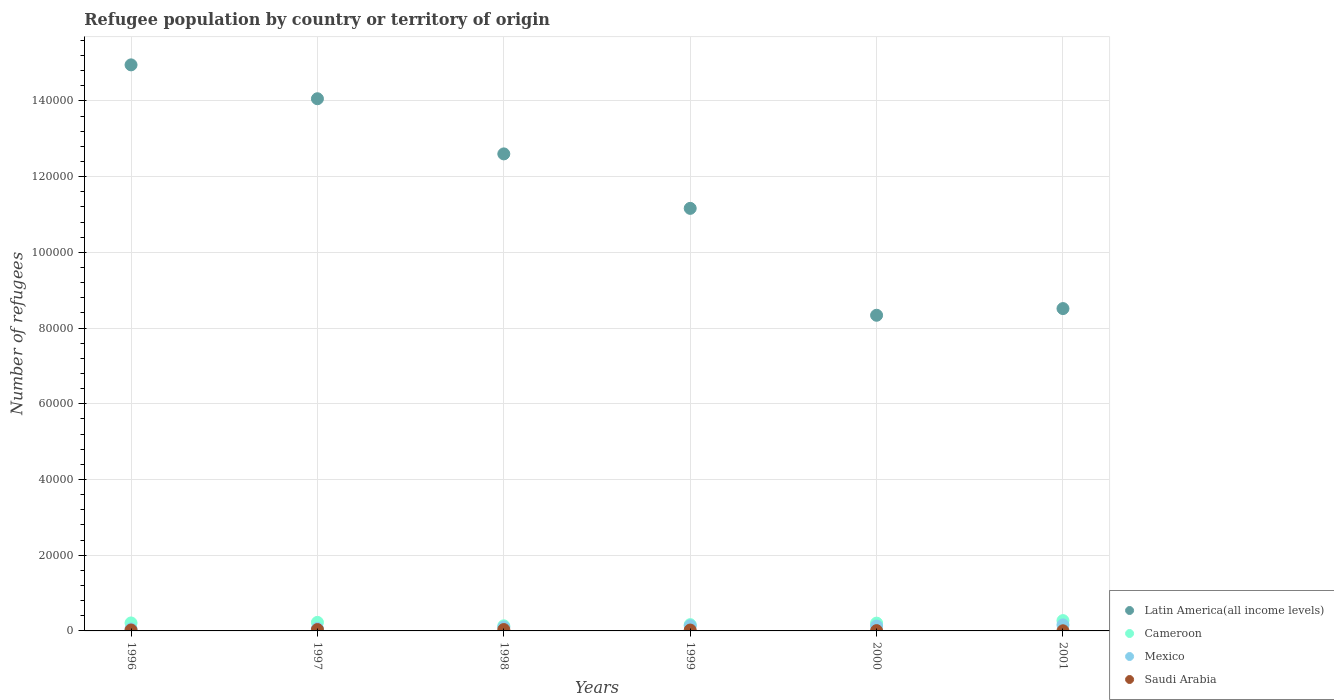Is the number of dotlines equal to the number of legend labels?
Your answer should be compact. Yes. What is the number of refugees in Saudi Arabia in 1999?
Give a very brief answer. 233. Across all years, what is the maximum number of refugees in Mexico?
Give a very brief answer. 1594. In which year was the number of refugees in Mexico maximum?
Offer a very short reply. 2001. What is the total number of refugees in Latin America(all income levels) in the graph?
Your answer should be compact. 6.96e+05. What is the difference between the number of refugees in Cameroon in 1999 and that in 2000?
Your answer should be very brief. -408. What is the difference between the number of refugees in Saudi Arabia in 1997 and the number of refugees in Mexico in 1999?
Offer a terse response. -1001. What is the average number of refugees in Mexico per year?
Ensure brevity in your answer.  1074.17. In the year 1998, what is the difference between the number of refugees in Latin America(all income levels) and number of refugees in Mexico?
Your response must be concise. 1.25e+05. In how many years, is the number of refugees in Cameroon greater than 148000?
Your answer should be very brief. 0. What is the ratio of the number of refugees in Mexico in 1997 to that in 2001?
Keep it short and to the point. 0.42. Is the number of refugees in Cameroon in 1996 less than that in 1999?
Provide a short and direct response. No. What is the difference between the highest and the second highest number of refugees in Latin America(all income levels)?
Offer a terse response. 8946. What is the difference between the highest and the lowest number of refugees in Latin America(all income levels)?
Your answer should be compact. 6.61e+04. Is it the case that in every year, the sum of the number of refugees in Saudi Arabia and number of refugees in Latin America(all income levels)  is greater than the number of refugees in Mexico?
Your answer should be very brief. Yes. Are the values on the major ticks of Y-axis written in scientific E-notation?
Provide a succinct answer. No. Does the graph contain any zero values?
Keep it short and to the point. No. Does the graph contain grids?
Give a very brief answer. Yes. How are the legend labels stacked?
Your answer should be compact. Vertical. What is the title of the graph?
Make the answer very short. Refugee population by country or territory of origin. What is the label or title of the X-axis?
Your response must be concise. Years. What is the label or title of the Y-axis?
Give a very brief answer. Number of refugees. What is the Number of refugees in Latin America(all income levels) in 1996?
Give a very brief answer. 1.50e+05. What is the Number of refugees of Cameroon in 1996?
Keep it short and to the point. 2109. What is the Number of refugees of Mexico in 1996?
Your answer should be compact. 520. What is the Number of refugees of Saudi Arabia in 1996?
Provide a short and direct response. 242. What is the Number of refugees in Latin America(all income levels) in 1997?
Make the answer very short. 1.41e+05. What is the Number of refugees of Cameroon in 1997?
Give a very brief answer. 2258. What is the Number of refugees of Mexico in 1997?
Provide a short and direct response. 665. What is the Number of refugees in Saudi Arabia in 1997?
Give a very brief answer. 358. What is the Number of refugees of Latin America(all income levels) in 1998?
Provide a succinct answer. 1.26e+05. What is the Number of refugees in Cameroon in 1998?
Keep it short and to the point. 1348. What is the Number of refugees of Mexico in 1998?
Keep it short and to the point. 1016. What is the Number of refugees of Saudi Arabia in 1998?
Provide a short and direct response. 362. What is the Number of refugees in Latin America(all income levels) in 1999?
Your response must be concise. 1.12e+05. What is the Number of refugees of Cameroon in 1999?
Your answer should be very brief. 1654. What is the Number of refugees in Mexico in 1999?
Your answer should be very brief. 1359. What is the Number of refugees in Saudi Arabia in 1999?
Keep it short and to the point. 233. What is the Number of refugees of Latin America(all income levels) in 2000?
Ensure brevity in your answer.  8.34e+04. What is the Number of refugees in Cameroon in 2000?
Provide a succinct answer. 2062. What is the Number of refugees in Mexico in 2000?
Keep it short and to the point. 1291. What is the Number of refugees of Latin America(all income levels) in 2001?
Offer a terse response. 8.52e+04. What is the Number of refugees in Cameroon in 2001?
Your answer should be compact. 2724. What is the Number of refugees of Mexico in 2001?
Offer a very short reply. 1594. What is the Number of refugees in Saudi Arabia in 2001?
Offer a terse response. 35. Across all years, what is the maximum Number of refugees of Latin America(all income levels)?
Ensure brevity in your answer.  1.50e+05. Across all years, what is the maximum Number of refugees of Cameroon?
Give a very brief answer. 2724. Across all years, what is the maximum Number of refugees of Mexico?
Ensure brevity in your answer.  1594. Across all years, what is the maximum Number of refugees of Saudi Arabia?
Make the answer very short. 362. Across all years, what is the minimum Number of refugees of Latin America(all income levels)?
Make the answer very short. 8.34e+04. Across all years, what is the minimum Number of refugees of Cameroon?
Provide a short and direct response. 1348. Across all years, what is the minimum Number of refugees of Mexico?
Make the answer very short. 520. Across all years, what is the minimum Number of refugees of Saudi Arabia?
Offer a terse response. 35. What is the total Number of refugees in Latin America(all income levels) in the graph?
Give a very brief answer. 6.96e+05. What is the total Number of refugees in Cameroon in the graph?
Give a very brief answer. 1.22e+04. What is the total Number of refugees of Mexico in the graph?
Ensure brevity in your answer.  6445. What is the total Number of refugees of Saudi Arabia in the graph?
Provide a succinct answer. 1307. What is the difference between the Number of refugees in Latin America(all income levels) in 1996 and that in 1997?
Your response must be concise. 8946. What is the difference between the Number of refugees of Cameroon in 1996 and that in 1997?
Your response must be concise. -149. What is the difference between the Number of refugees in Mexico in 1996 and that in 1997?
Your response must be concise. -145. What is the difference between the Number of refugees of Saudi Arabia in 1996 and that in 1997?
Your response must be concise. -116. What is the difference between the Number of refugees in Latin America(all income levels) in 1996 and that in 1998?
Give a very brief answer. 2.35e+04. What is the difference between the Number of refugees of Cameroon in 1996 and that in 1998?
Provide a succinct answer. 761. What is the difference between the Number of refugees in Mexico in 1996 and that in 1998?
Offer a terse response. -496. What is the difference between the Number of refugees in Saudi Arabia in 1996 and that in 1998?
Your response must be concise. -120. What is the difference between the Number of refugees of Latin America(all income levels) in 1996 and that in 1999?
Make the answer very short. 3.79e+04. What is the difference between the Number of refugees of Cameroon in 1996 and that in 1999?
Make the answer very short. 455. What is the difference between the Number of refugees of Mexico in 1996 and that in 1999?
Your answer should be compact. -839. What is the difference between the Number of refugees in Saudi Arabia in 1996 and that in 1999?
Offer a terse response. 9. What is the difference between the Number of refugees in Latin America(all income levels) in 1996 and that in 2000?
Ensure brevity in your answer.  6.61e+04. What is the difference between the Number of refugees of Cameroon in 1996 and that in 2000?
Offer a terse response. 47. What is the difference between the Number of refugees of Mexico in 1996 and that in 2000?
Offer a very short reply. -771. What is the difference between the Number of refugees of Saudi Arabia in 1996 and that in 2000?
Give a very brief answer. 165. What is the difference between the Number of refugees in Latin America(all income levels) in 1996 and that in 2001?
Make the answer very short. 6.44e+04. What is the difference between the Number of refugees in Cameroon in 1996 and that in 2001?
Make the answer very short. -615. What is the difference between the Number of refugees of Mexico in 1996 and that in 2001?
Make the answer very short. -1074. What is the difference between the Number of refugees of Saudi Arabia in 1996 and that in 2001?
Provide a short and direct response. 207. What is the difference between the Number of refugees in Latin America(all income levels) in 1997 and that in 1998?
Give a very brief answer. 1.46e+04. What is the difference between the Number of refugees of Cameroon in 1997 and that in 1998?
Give a very brief answer. 910. What is the difference between the Number of refugees in Mexico in 1997 and that in 1998?
Provide a short and direct response. -351. What is the difference between the Number of refugees in Latin America(all income levels) in 1997 and that in 1999?
Offer a very short reply. 2.90e+04. What is the difference between the Number of refugees in Cameroon in 1997 and that in 1999?
Offer a very short reply. 604. What is the difference between the Number of refugees in Mexico in 1997 and that in 1999?
Your answer should be compact. -694. What is the difference between the Number of refugees of Saudi Arabia in 1997 and that in 1999?
Make the answer very short. 125. What is the difference between the Number of refugees in Latin America(all income levels) in 1997 and that in 2000?
Ensure brevity in your answer.  5.72e+04. What is the difference between the Number of refugees of Cameroon in 1997 and that in 2000?
Your response must be concise. 196. What is the difference between the Number of refugees of Mexico in 1997 and that in 2000?
Ensure brevity in your answer.  -626. What is the difference between the Number of refugees of Saudi Arabia in 1997 and that in 2000?
Your response must be concise. 281. What is the difference between the Number of refugees in Latin America(all income levels) in 1997 and that in 2001?
Your answer should be compact. 5.54e+04. What is the difference between the Number of refugees in Cameroon in 1997 and that in 2001?
Provide a short and direct response. -466. What is the difference between the Number of refugees in Mexico in 1997 and that in 2001?
Keep it short and to the point. -929. What is the difference between the Number of refugees in Saudi Arabia in 1997 and that in 2001?
Provide a succinct answer. 323. What is the difference between the Number of refugees in Latin America(all income levels) in 1998 and that in 1999?
Offer a very short reply. 1.44e+04. What is the difference between the Number of refugees of Cameroon in 1998 and that in 1999?
Provide a short and direct response. -306. What is the difference between the Number of refugees of Mexico in 1998 and that in 1999?
Make the answer very short. -343. What is the difference between the Number of refugees of Saudi Arabia in 1998 and that in 1999?
Provide a short and direct response. 129. What is the difference between the Number of refugees in Latin America(all income levels) in 1998 and that in 2000?
Offer a terse response. 4.26e+04. What is the difference between the Number of refugees in Cameroon in 1998 and that in 2000?
Provide a succinct answer. -714. What is the difference between the Number of refugees in Mexico in 1998 and that in 2000?
Give a very brief answer. -275. What is the difference between the Number of refugees of Saudi Arabia in 1998 and that in 2000?
Your answer should be very brief. 285. What is the difference between the Number of refugees in Latin America(all income levels) in 1998 and that in 2001?
Make the answer very short. 4.09e+04. What is the difference between the Number of refugees in Cameroon in 1998 and that in 2001?
Offer a terse response. -1376. What is the difference between the Number of refugees in Mexico in 1998 and that in 2001?
Give a very brief answer. -578. What is the difference between the Number of refugees in Saudi Arabia in 1998 and that in 2001?
Give a very brief answer. 327. What is the difference between the Number of refugees in Latin America(all income levels) in 1999 and that in 2000?
Your answer should be very brief. 2.82e+04. What is the difference between the Number of refugees of Cameroon in 1999 and that in 2000?
Keep it short and to the point. -408. What is the difference between the Number of refugees in Saudi Arabia in 1999 and that in 2000?
Offer a terse response. 156. What is the difference between the Number of refugees of Latin America(all income levels) in 1999 and that in 2001?
Offer a very short reply. 2.65e+04. What is the difference between the Number of refugees in Cameroon in 1999 and that in 2001?
Keep it short and to the point. -1070. What is the difference between the Number of refugees in Mexico in 1999 and that in 2001?
Your answer should be very brief. -235. What is the difference between the Number of refugees of Saudi Arabia in 1999 and that in 2001?
Ensure brevity in your answer.  198. What is the difference between the Number of refugees in Latin America(all income levels) in 2000 and that in 2001?
Offer a very short reply. -1765. What is the difference between the Number of refugees in Cameroon in 2000 and that in 2001?
Make the answer very short. -662. What is the difference between the Number of refugees of Mexico in 2000 and that in 2001?
Your answer should be very brief. -303. What is the difference between the Number of refugees of Latin America(all income levels) in 1996 and the Number of refugees of Cameroon in 1997?
Your answer should be very brief. 1.47e+05. What is the difference between the Number of refugees in Latin America(all income levels) in 1996 and the Number of refugees in Mexico in 1997?
Make the answer very short. 1.49e+05. What is the difference between the Number of refugees in Latin America(all income levels) in 1996 and the Number of refugees in Saudi Arabia in 1997?
Offer a very short reply. 1.49e+05. What is the difference between the Number of refugees of Cameroon in 1996 and the Number of refugees of Mexico in 1997?
Ensure brevity in your answer.  1444. What is the difference between the Number of refugees of Cameroon in 1996 and the Number of refugees of Saudi Arabia in 1997?
Your answer should be compact. 1751. What is the difference between the Number of refugees of Mexico in 1996 and the Number of refugees of Saudi Arabia in 1997?
Provide a short and direct response. 162. What is the difference between the Number of refugees of Latin America(all income levels) in 1996 and the Number of refugees of Cameroon in 1998?
Provide a succinct answer. 1.48e+05. What is the difference between the Number of refugees in Latin America(all income levels) in 1996 and the Number of refugees in Mexico in 1998?
Your answer should be very brief. 1.49e+05. What is the difference between the Number of refugees of Latin America(all income levels) in 1996 and the Number of refugees of Saudi Arabia in 1998?
Offer a terse response. 1.49e+05. What is the difference between the Number of refugees in Cameroon in 1996 and the Number of refugees in Mexico in 1998?
Your response must be concise. 1093. What is the difference between the Number of refugees in Cameroon in 1996 and the Number of refugees in Saudi Arabia in 1998?
Keep it short and to the point. 1747. What is the difference between the Number of refugees of Mexico in 1996 and the Number of refugees of Saudi Arabia in 1998?
Keep it short and to the point. 158. What is the difference between the Number of refugees in Latin America(all income levels) in 1996 and the Number of refugees in Cameroon in 1999?
Keep it short and to the point. 1.48e+05. What is the difference between the Number of refugees in Latin America(all income levels) in 1996 and the Number of refugees in Mexico in 1999?
Provide a succinct answer. 1.48e+05. What is the difference between the Number of refugees of Latin America(all income levels) in 1996 and the Number of refugees of Saudi Arabia in 1999?
Your answer should be very brief. 1.49e+05. What is the difference between the Number of refugees of Cameroon in 1996 and the Number of refugees of Mexico in 1999?
Offer a terse response. 750. What is the difference between the Number of refugees of Cameroon in 1996 and the Number of refugees of Saudi Arabia in 1999?
Provide a succinct answer. 1876. What is the difference between the Number of refugees in Mexico in 1996 and the Number of refugees in Saudi Arabia in 1999?
Offer a terse response. 287. What is the difference between the Number of refugees in Latin America(all income levels) in 1996 and the Number of refugees in Cameroon in 2000?
Provide a succinct answer. 1.47e+05. What is the difference between the Number of refugees of Latin America(all income levels) in 1996 and the Number of refugees of Mexico in 2000?
Offer a terse response. 1.48e+05. What is the difference between the Number of refugees of Latin America(all income levels) in 1996 and the Number of refugees of Saudi Arabia in 2000?
Offer a terse response. 1.49e+05. What is the difference between the Number of refugees of Cameroon in 1996 and the Number of refugees of Mexico in 2000?
Offer a terse response. 818. What is the difference between the Number of refugees in Cameroon in 1996 and the Number of refugees in Saudi Arabia in 2000?
Keep it short and to the point. 2032. What is the difference between the Number of refugees in Mexico in 1996 and the Number of refugees in Saudi Arabia in 2000?
Your answer should be very brief. 443. What is the difference between the Number of refugees of Latin America(all income levels) in 1996 and the Number of refugees of Cameroon in 2001?
Provide a succinct answer. 1.47e+05. What is the difference between the Number of refugees of Latin America(all income levels) in 1996 and the Number of refugees of Mexico in 2001?
Your answer should be compact. 1.48e+05. What is the difference between the Number of refugees of Latin America(all income levels) in 1996 and the Number of refugees of Saudi Arabia in 2001?
Offer a very short reply. 1.50e+05. What is the difference between the Number of refugees in Cameroon in 1996 and the Number of refugees in Mexico in 2001?
Your answer should be very brief. 515. What is the difference between the Number of refugees in Cameroon in 1996 and the Number of refugees in Saudi Arabia in 2001?
Your response must be concise. 2074. What is the difference between the Number of refugees of Mexico in 1996 and the Number of refugees of Saudi Arabia in 2001?
Keep it short and to the point. 485. What is the difference between the Number of refugees in Latin America(all income levels) in 1997 and the Number of refugees in Cameroon in 1998?
Give a very brief answer. 1.39e+05. What is the difference between the Number of refugees of Latin America(all income levels) in 1997 and the Number of refugees of Mexico in 1998?
Provide a succinct answer. 1.40e+05. What is the difference between the Number of refugees of Latin America(all income levels) in 1997 and the Number of refugees of Saudi Arabia in 1998?
Keep it short and to the point. 1.40e+05. What is the difference between the Number of refugees of Cameroon in 1997 and the Number of refugees of Mexico in 1998?
Provide a succinct answer. 1242. What is the difference between the Number of refugees in Cameroon in 1997 and the Number of refugees in Saudi Arabia in 1998?
Keep it short and to the point. 1896. What is the difference between the Number of refugees of Mexico in 1997 and the Number of refugees of Saudi Arabia in 1998?
Ensure brevity in your answer.  303. What is the difference between the Number of refugees in Latin America(all income levels) in 1997 and the Number of refugees in Cameroon in 1999?
Keep it short and to the point. 1.39e+05. What is the difference between the Number of refugees in Latin America(all income levels) in 1997 and the Number of refugees in Mexico in 1999?
Make the answer very short. 1.39e+05. What is the difference between the Number of refugees of Latin America(all income levels) in 1997 and the Number of refugees of Saudi Arabia in 1999?
Provide a succinct answer. 1.40e+05. What is the difference between the Number of refugees in Cameroon in 1997 and the Number of refugees in Mexico in 1999?
Provide a short and direct response. 899. What is the difference between the Number of refugees in Cameroon in 1997 and the Number of refugees in Saudi Arabia in 1999?
Ensure brevity in your answer.  2025. What is the difference between the Number of refugees in Mexico in 1997 and the Number of refugees in Saudi Arabia in 1999?
Give a very brief answer. 432. What is the difference between the Number of refugees of Latin America(all income levels) in 1997 and the Number of refugees of Cameroon in 2000?
Provide a short and direct response. 1.39e+05. What is the difference between the Number of refugees in Latin America(all income levels) in 1997 and the Number of refugees in Mexico in 2000?
Ensure brevity in your answer.  1.39e+05. What is the difference between the Number of refugees of Latin America(all income levels) in 1997 and the Number of refugees of Saudi Arabia in 2000?
Make the answer very short. 1.41e+05. What is the difference between the Number of refugees of Cameroon in 1997 and the Number of refugees of Mexico in 2000?
Ensure brevity in your answer.  967. What is the difference between the Number of refugees of Cameroon in 1997 and the Number of refugees of Saudi Arabia in 2000?
Make the answer very short. 2181. What is the difference between the Number of refugees of Mexico in 1997 and the Number of refugees of Saudi Arabia in 2000?
Offer a very short reply. 588. What is the difference between the Number of refugees of Latin America(all income levels) in 1997 and the Number of refugees of Cameroon in 2001?
Your answer should be compact. 1.38e+05. What is the difference between the Number of refugees in Latin America(all income levels) in 1997 and the Number of refugees in Mexico in 2001?
Make the answer very short. 1.39e+05. What is the difference between the Number of refugees in Latin America(all income levels) in 1997 and the Number of refugees in Saudi Arabia in 2001?
Provide a short and direct response. 1.41e+05. What is the difference between the Number of refugees in Cameroon in 1997 and the Number of refugees in Mexico in 2001?
Keep it short and to the point. 664. What is the difference between the Number of refugees of Cameroon in 1997 and the Number of refugees of Saudi Arabia in 2001?
Your answer should be compact. 2223. What is the difference between the Number of refugees of Mexico in 1997 and the Number of refugees of Saudi Arabia in 2001?
Your answer should be very brief. 630. What is the difference between the Number of refugees in Latin America(all income levels) in 1998 and the Number of refugees in Cameroon in 1999?
Your response must be concise. 1.24e+05. What is the difference between the Number of refugees in Latin America(all income levels) in 1998 and the Number of refugees in Mexico in 1999?
Your answer should be compact. 1.25e+05. What is the difference between the Number of refugees in Latin America(all income levels) in 1998 and the Number of refugees in Saudi Arabia in 1999?
Your response must be concise. 1.26e+05. What is the difference between the Number of refugees of Cameroon in 1998 and the Number of refugees of Mexico in 1999?
Offer a terse response. -11. What is the difference between the Number of refugees in Cameroon in 1998 and the Number of refugees in Saudi Arabia in 1999?
Give a very brief answer. 1115. What is the difference between the Number of refugees of Mexico in 1998 and the Number of refugees of Saudi Arabia in 1999?
Your response must be concise. 783. What is the difference between the Number of refugees in Latin America(all income levels) in 1998 and the Number of refugees in Cameroon in 2000?
Ensure brevity in your answer.  1.24e+05. What is the difference between the Number of refugees in Latin America(all income levels) in 1998 and the Number of refugees in Mexico in 2000?
Ensure brevity in your answer.  1.25e+05. What is the difference between the Number of refugees in Latin America(all income levels) in 1998 and the Number of refugees in Saudi Arabia in 2000?
Offer a very short reply. 1.26e+05. What is the difference between the Number of refugees in Cameroon in 1998 and the Number of refugees in Mexico in 2000?
Offer a terse response. 57. What is the difference between the Number of refugees in Cameroon in 1998 and the Number of refugees in Saudi Arabia in 2000?
Offer a terse response. 1271. What is the difference between the Number of refugees of Mexico in 1998 and the Number of refugees of Saudi Arabia in 2000?
Make the answer very short. 939. What is the difference between the Number of refugees in Latin America(all income levels) in 1998 and the Number of refugees in Cameroon in 2001?
Your response must be concise. 1.23e+05. What is the difference between the Number of refugees of Latin America(all income levels) in 1998 and the Number of refugees of Mexico in 2001?
Your response must be concise. 1.24e+05. What is the difference between the Number of refugees in Latin America(all income levels) in 1998 and the Number of refugees in Saudi Arabia in 2001?
Provide a short and direct response. 1.26e+05. What is the difference between the Number of refugees of Cameroon in 1998 and the Number of refugees of Mexico in 2001?
Your response must be concise. -246. What is the difference between the Number of refugees of Cameroon in 1998 and the Number of refugees of Saudi Arabia in 2001?
Your answer should be compact. 1313. What is the difference between the Number of refugees of Mexico in 1998 and the Number of refugees of Saudi Arabia in 2001?
Provide a succinct answer. 981. What is the difference between the Number of refugees of Latin America(all income levels) in 1999 and the Number of refugees of Cameroon in 2000?
Your answer should be very brief. 1.10e+05. What is the difference between the Number of refugees in Latin America(all income levels) in 1999 and the Number of refugees in Mexico in 2000?
Make the answer very short. 1.10e+05. What is the difference between the Number of refugees of Latin America(all income levels) in 1999 and the Number of refugees of Saudi Arabia in 2000?
Keep it short and to the point. 1.12e+05. What is the difference between the Number of refugees in Cameroon in 1999 and the Number of refugees in Mexico in 2000?
Your response must be concise. 363. What is the difference between the Number of refugees in Cameroon in 1999 and the Number of refugees in Saudi Arabia in 2000?
Offer a very short reply. 1577. What is the difference between the Number of refugees in Mexico in 1999 and the Number of refugees in Saudi Arabia in 2000?
Make the answer very short. 1282. What is the difference between the Number of refugees in Latin America(all income levels) in 1999 and the Number of refugees in Cameroon in 2001?
Ensure brevity in your answer.  1.09e+05. What is the difference between the Number of refugees in Latin America(all income levels) in 1999 and the Number of refugees in Mexico in 2001?
Offer a terse response. 1.10e+05. What is the difference between the Number of refugees in Latin America(all income levels) in 1999 and the Number of refugees in Saudi Arabia in 2001?
Offer a very short reply. 1.12e+05. What is the difference between the Number of refugees of Cameroon in 1999 and the Number of refugees of Saudi Arabia in 2001?
Offer a terse response. 1619. What is the difference between the Number of refugees in Mexico in 1999 and the Number of refugees in Saudi Arabia in 2001?
Give a very brief answer. 1324. What is the difference between the Number of refugees in Latin America(all income levels) in 2000 and the Number of refugees in Cameroon in 2001?
Keep it short and to the point. 8.07e+04. What is the difference between the Number of refugees in Latin America(all income levels) in 2000 and the Number of refugees in Mexico in 2001?
Make the answer very short. 8.18e+04. What is the difference between the Number of refugees in Latin America(all income levels) in 2000 and the Number of refugees in Saudi Arabia in 2001?
Offer a terse response. 8.34e+04. What is the difference between the Number of refugees in Cameroon in 2000 and the Number of refugees in Mexico in 2001?
Offer a terse response. 468. What is the difference between the Number of refugees of Cameroon in 2000 and the Number of refugees of Saudi Arabia in 2001?
Provide a short and direct response. 2027. What is the difference between the Number of refugees of Mexico in 2000 and the Number of refugees of Saudi Arabia in 2001?
Your answer should be compact. 1256. What is the average Number of refugees of Latin America(all income levels) per year?
Give a very brief answer. 1.16e+05. What is the average Number of refugees of Cameroon per year?
Provide a short and direct response. 2025.83. What is the average Number of refugees in Mexico per year?
Give a very brief answer. 1074.17. What is the average Number of refugees of Saudi Arabia per year?
Your response must be concise. 217.83. In the year 1996, what is the difference between the Number of refugees of Latin America(all income levels) and Number of refugees of Cameroon?
Your response must be concise. 1.47e+05. In the year 1996, what is the difference between the Number of refugees in Latin America(all income levels) and Number of refugees in Mexico?
Your answer should be compact. 1.49e+05. In the year 1996, what is the difference between the Number of refugees in Latin America(all income levels) and Number of refugees in Saudi Arabia?
Give a very brief answer. 1.49e+05. In the year 1996, what is the difference between the Number of refugees of Cameroon and Number of refugees of Mexico?
Offer a terse response. 1589. In the year 1996, what is the difference between the Number of refugees of Cameroon and Number of refugees of Saudi Arabia?
Ensure brevity in your answer.  1867. In the year 1996, what is the difference between the Number of refugees of Mexico and Number of refugees of Saudi Arabia?
Offer a terse response. 278. In the year 1997, what is the difference between the Number of refugees in Latin America(all income levels) and Number of refugees in Cameroon?
Provide a short and direct response. 1.38e+05. In the year 1997, what is the difference between the Number of refugees in Latin America(all income levels) and Number of refugees in Mexico?
Provide a short and direct response. 1.40e+05. In the year 1997, what is the difference between the Number of refugees of Latin America(all income levels) and Number of refugees of Saudi Arabia?
Provide a short and direct response. 1.40e+05. In the year 1997, what is the difference between the Number of refugees of Cameroon and Number of refugees of Mexico?
Your answer should be very brief. 1593. In the year 1997, what is the difference between the Number of refugees in Cameroon and Number of refugees in Saudi Arabia?
Offer a terse response. 1900. In the year 1997, what is the difference between the Number of refugees in Mexico and Number of refugees in Saudi Arabia?
Give a very brief answer. 307. In the year 1998, what is the difference between the Number of refugees in Latin America(all income levels) and Number of refugees in Cameroon?
Ensure brevity in your answer.  1.25e+05. In the year 1998, what is the difference between the Number of refugees of Latin America(all income levels) and Number of refugees of Mexico?
Provide a short and direct response. 1.25e+05. In the year 1998, what is the difference between the Number of refugees in Latin America(all income levels) and Number of refugees in Saudi Arabia?
Keep it short and to the point. 1.26e+05. In the year 1998, what is the difference between the Number of refugees in Cameroon and Number of refugees in Mexico?
Give a very brief answer. 332. In the year 1998, what is the difference between the Number of refugees in Cameroon and Number of refugees in Saudi Arabia?
Provide a short and direct response. 986. In the year 1998, what is the difference between the Number of refugees in Mexico and Number of refugees in Saudi Arabia?
Offer a terse response. 654. In the year 1999, what is the difference between the Number of refugees in Latin America(all income levels) and Number of refugees in Cameroon?
Keep it short and to the point. 1.10e+05. In the year 1999, what is the difference between the Number of refugees of Latin America(all income levels) and Number of refugees of Mexico?
Provide a succinct answer. 1.10e+05. In the year 1999, what is the difference between the Number of refugees of Latin America(all income levels) and Number of refugees of Saudi Arabia?
Offer a terse response. 1.11e+05. In the year 1999, what is the difference between the Number of refugees of Cameroon and Number of refugees of Mexico?
Offer a very short reply. 295. In the year 1999, what is the difference between the Number of refugees in Cameroon and Number of refugees in Saudi Arabia?
Provide a short and direct response. 1421. In the year 1999, what is the difference between the Number of refugees in Mexico and Number of refugees in Saudi Arabia?
Keep it short and to the point. 1126. In the year 2000, what is the difference between the Number of refugees of Latin America(all income levels) and Number of refugees of Cameroon?
Provide a short and direct response. 8.13e+04. In the year 2000, what is the difference between the Number of refugees of Latin America(all income levels) and Number of refugees of Mexico?
Offer a very short reply. 8.21e+04. In the year 2000, what is the difference between the Number of refugees in Latin America(all income levels) and Number of refugees in Saudi Arabia?
Make the answer very short. 8.33e+04. In the year 2000, what is the difference between the Number of refugees of Cameroon and Number of refugees of Mexico?
Keep it short and to the point. 771. In the year 2000, what is the difference between the Number of refugees in Cameroon and Number of refugees in Saudi Arabia?
Offer a terse response. 1985. In the year 2000, what is the difference between the Number of refugees of Mexico and Number of refugees of Saudi Arabia?
Make the answer very short. 1214. In the year 2001, what is the difference between the Number of refugees in Latin America(all income levels) and Number of refugees in Cameroon?
Give a very brief answer. 8.24e+04. In the year 2001, what is the difference between the Number of refugees in Latin America(all income levels) and Number of refugees in Mexico?
Ensure brevity in your answer.  8.36e+04. In the year 2001, what is the difference between the Number of refugees of Latin America(all income levels) and Number of refugees of Saudi Arabia?
Offer a terse response. 8.51e+04. In the year 2001, what is the difference between the Number of refugees in Cameroon and Number of refugees in Mexico?
Make the answer very short. 1130. In the year 2001, what is the difference between the Number of refugees in Cameroon and Number of refugees in Saudi Arabia?
Ensure brevity in your answer.  2689. In the year 2001, what is the difference between the Number of refugees of Mexico and Number of refugees of Saudi Arabia?
Keep it short and to the point. 1559. What is the ratio of the Number of refugees in Latin America(all income levels) in 1996 to that in 1997?
Your answer should be compact. 1.06. What is the ratio of the Number of refugees in Cameroon in 1996 to that in 1997?
Ensure brevity in your answer.  0.93. What is the ratio of the Number of refugees of Mexico in 1996 to that in 1997?
Provide a succinct answer. 0.78. What is the ratio of the Number of refugees in Saudi Arabia in 1996 to that in 1997?
Ensure brevity in your answer.  0.68. What is the ratio of the Number of refugees in Latin America(all income levels) in 1996 to that in 1998?
Give a very brief answer. 1.19. What is the ratio of the Number of refugees of Cameroon in 1996 to that in 1998?
Make the answer very short. 1.56. What is the ratio of the Number of refugees in Mexico in 1996 to that in 1998?
Ensure brevity in your answer.  0.51. What is the ratio of the Number of refugees in Saudi Arabia in 1996 to that in 1998?
Your response must be concise. 0.67. What is the ratio of the Number of refugees in Latin America(all income levels) in 1996 to that in 1999?
Your answer should be very brief. 1.34. What is the ratio of the Number of refugees in Cameroon in 1996 to that in 1999?
Offer a very short reply. 1.28. What is the ratio of the Number of refugees of Mexico in 1996 to that in 1999?
Your answer should be compact. 0.38. What is the ratio of the Number of refugees in Saudi Arabia in 1996 to that in 1999?
Offer a terse response. 1.04. What is the ratio of the Number of refugees in Latin America(all income levels) in 1996 to that in 2000?
Keep it short and to the point. 1.79. What is the ratio of the Number of refugees of Cameroon in 1996 to that in 2000?
Your answer should be very brief. 1.02. What is the ratio of the Number of refugees of Mexico in 1996 to that in 2000?
Provide a short and direct response. 0.4. What is the ratio of the Number of refugees of Saudi Arabia in 1996 to that in 2000?
Give a very brief answer. 3.14. What is the ratio of the Number of refugees in Latin America(all income levels) in 1996 to that in 2001?
Offer a very short reply. 1.76. What is the ratio of the Number of refugees in Cameroon in 1996 to that in 2001?
Provide a short and direct response. 0.77. What is the ratio of the Number of refugees in Mexico in 1996 to that in 2001?
Provide a short and direct response. 0.33. What is the ratio of the Number of refugees of Saudi Arabia in 1996 to that in 2001?
Make the answer very short. 6.91. What is the ratio of the Number of refugees in Latin America(all income levels) in 1997 to that in 1998?
Offer a very short reply. 1.12. What is the ratio of the Number of refugees of Cameroon in 1997 to that in 1998?
Make the answer very short. 1.68. What is the ratio of the Number of refugees of Mexico in 1997 to that in 1998?
Give a very brief answer. 0.65. What is the ratio of the Number of refugees of Latin America(all income levels) in 1997 to that in 1999?
Provide a succinct answer. 1.26. What is the ratio of the Number of refugees in Cameroon in 1997 to that in 1999?
Your answer should be compact. 1.37. What is the ratio of the Number of refugees in Mexico in 1997 to that in 1999?
Your answer should be very brief. 0.49. What is the ratio of the Number of refugees in Saudi Arabia in 1997 to that in 1999?
Keep it short and to the point. 1.54. What is the ratio of the Number of refugees of Latin America(all income levels) in 1997 to that in 2000?
Offer a terse response. 1.69. What is the ratio of the Number of refugees of Cameroon in 1997 to that in 2000?
Give a very brief answer. 1.1. What is the ratio of the Number of refugees of Mexico in 1997 to that in 2000?
Keep it short and to the point. 0.52. What is the ratio of the Number of refugees of Saudi Arabia in 1997 to that in 2000?
Make the answer very short. 4.65. What is the ratio of the Number of refugees of Latin America(all income levels) in 1997 to that in 2001?
Give a very brief answer. 1.65. What is the ratio of the Number of refugees in Cameroon in 1997 to that in 2001?
Offer a very short reply. 0.83. What is the ratio of the Number of refugees in Mexico in 1997 to that in 2001?
Provide a succinct answer. 0.42. What is the ratio of the Number of refugees of Saudi Arabia in 1997 to that in 2001?
Provide a succinct answer. 10.23. What is the ratio of the Number of refugees of Latin America(all income levels) in 1998 to that in 1999?
Give a very brief answer. 1.13. What is the ratio of the Number of refugees in Cameroon in 1998 to that in 1999?
Your answer should be very brief. 0.81. What is the ratio of the Number of refugees in Mexico in 1998 to that in 1999?
Ensure brevity in your answer.  0.75. What is the ratio of the Number of refugees in Saudi Arabia in 1998 to that in 1999?
Your response must be concise. 1.55. What is the ratio of the Number of refugees in Latin America(all income levels) in 1998 to that in 2000?
Make the answer very short. 1.51. What is the ratio of the Number of refugees in Cameroon in 1998 to that in 2000?
Offer a very short reply. 0.65. What is the ratio of the Number of refugees in Mexico in 1998 to that in 2000?
Ensure brevity in your answer.  0.79. What is the ratio of the Number of refugees of Saudi Arabia in 1998 to that in 2000?
Provide a short and direct response. 4.7. What is the ratio of the Number of refugees in Latin America(all income levels) in 1998 to that in 2001?
Keep it short and to the point. 1.48. What is the ratio of the Number of refugees of Cameroon in 1998 to that in 2001?
Provide a short and direct response. 0.49. What is the ratio of the Number of refugees of Mexico in 1998 to that in 2001?
Make the answer very short. 0.64. What is the ratio of the Number of refugees of Saudi Arabia in 1998 to that in 2001?
Your answer should be compact. 10.34. What is the ratio of the Number of refugees of Latin America(all income levels) in 1999 to that in 2000?
Ensure brevity in your answer.  1.34. What is the ratio of the Number of refugees in Cameroon in 1999 to that in 2000?
Provide a short and direct response. 0.8. What is the ratio of the Number of refugees of Mexico in 1999 to that in 2000?
Offer a terse response. 1.05. What is the ratio of the Number of refugees in Saudi Arabia in 1999 to that in 2000?
Ensure brevity in your answer.  3.03. What is the ratio of the Number of refugees in Latin America(all income levels) in 1999 to that in 2001?
Provide a succinct answer. 1.31. What is the ratio of the Number of refugees in Cameroon in 1999 to that in 2001?
Offer a very short reply. 0.61. What is the ratio of the Number of refugees in Mexico in 1999 to that in 2001?
Keep it short and to the point. 0.85. What is the ratio of the Number of refugees in Saudi Arabia in 1999 to that in 2001?
Offer a terse response. 6.66. What is the ratio of the Number of refugees in Latin America(all income levels) in 2000 to that in 2001?
Keep it short and to the point. 0.98. What is the ratio of the Number of refugees of Cameroon in 2000 to that in 2001?
Your response must be concise. 0.76. What is the ratio of the Number of refugees in Mexico in 2000 to that in 2001?
Ensure brevity in your answer.  0.81. What is the difference between the highest and the second highest Number of refugees of Latin America(all income levels)?
Make the answer very short. 8946. What is the difference between the highest and the second highest Number of refugees in Cameroon?
Your answer should be compact. 466. What is the difference between the highest and the second highest Number of refugees of Mexico?
Keep it short and to the point. 235. What is the difference between the highest and the second highest Number of refugees of Saudi Arabia?
Give a very brief answer. 4. What is the difference between the highest and the lowest Number of refugees in Latin America(all income levels)?
Give a very brief answer. 6.61e+04. What is the difference between the highest and the lowest Number of refugees in Cameroon?
Make the answer very short. 1376. What is the difference between the highest and the lowest Number of refugees of Mexico?
Your answer should be very brief. 1074. What is the difference between the highest and the lowest Number of refugees in Saudi Arabia?
Ensure brevity in your answer.  327. 